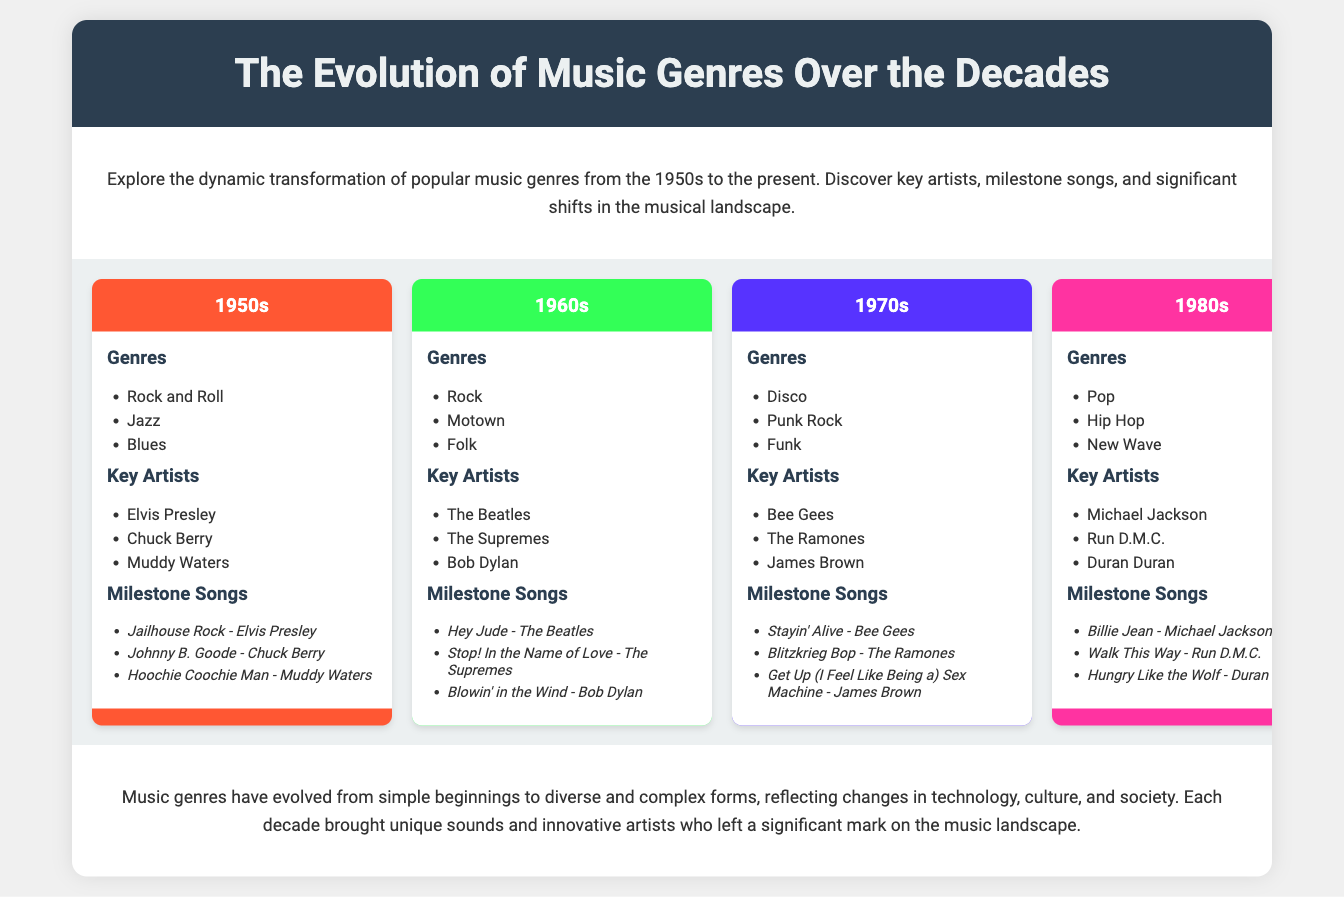What genre emerged in the 1950s? The document states that Rock and Roll, Jazz, and Blues were popular genres in the 1950s.
Answer: Rock and Roll Who was a key artist in the 1970s? The document lists Bee Gees, The Ramones, and James Brown as key artists of the 1970s.
Answer: Bee Gees What is a milestone song from the 1980s? The document mentions Billie Jean by Michael Jackson as a milestone song from the 1980s.
Answer: Billie Jean How many genres are listed for the 1990s? The 1990s section lists Grunge, R&B, and Britpop as genres.
Answer: Three Which decade featured the genre of Disco? The document indicates that Disco was a genre in the 1970s.
Answer: 1970s Which song represents the 2010s? The document highlights Summer by Calvin Harris as a significant song of the 2010s.
Answer: Summer What color represents the 2000s in the infographic? The document specifies that the 2000s decade is represented by the color #A1FF33.
Answer: #A1FF33 How many key artists are mentioned for the 1960s? According to the document, there are three key artists listed for the 1960s.
Answer: Three What significant shift does the conclusion mention? The conclusion addresses the evolution of music genres reflecting changes in technology, culture, and society.
Answer: Changes in technology, culture, and society 